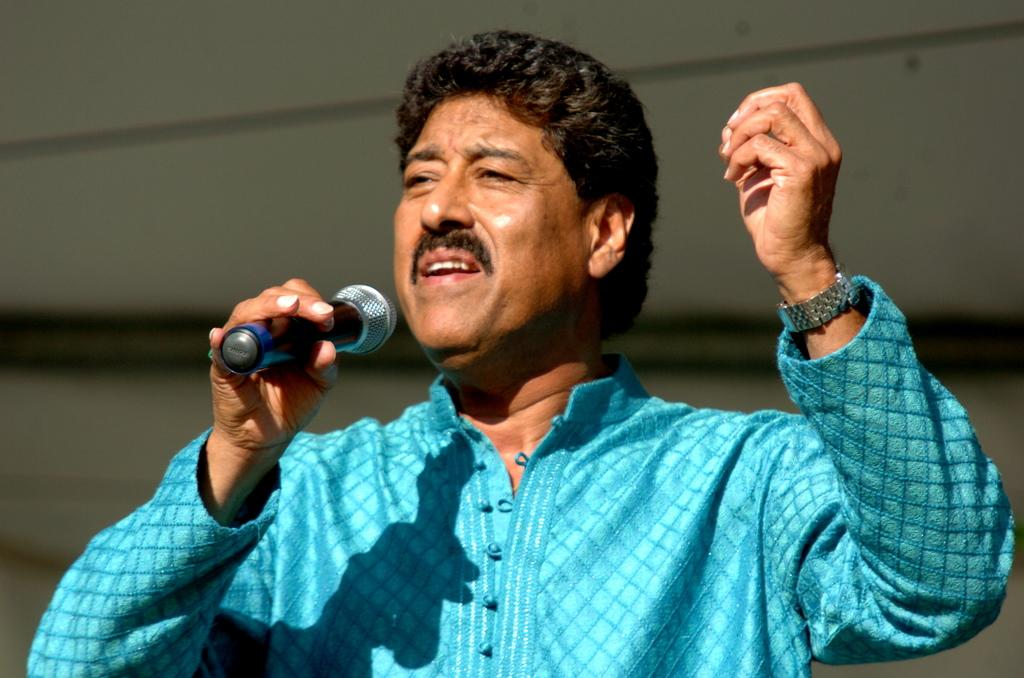Who is the main subject in the image? There is a man in the image. What is the man doing in the image? The man is standing and singing a song. What is the man wearing in the image? The man is wearing a blue color kurta and a wrist watch. What object is the man holding in the image? The man is holding a mike. How many stomachs does the man have in the image? The image does not show any information about the man's stomach, so it cannot be determined from the image. 